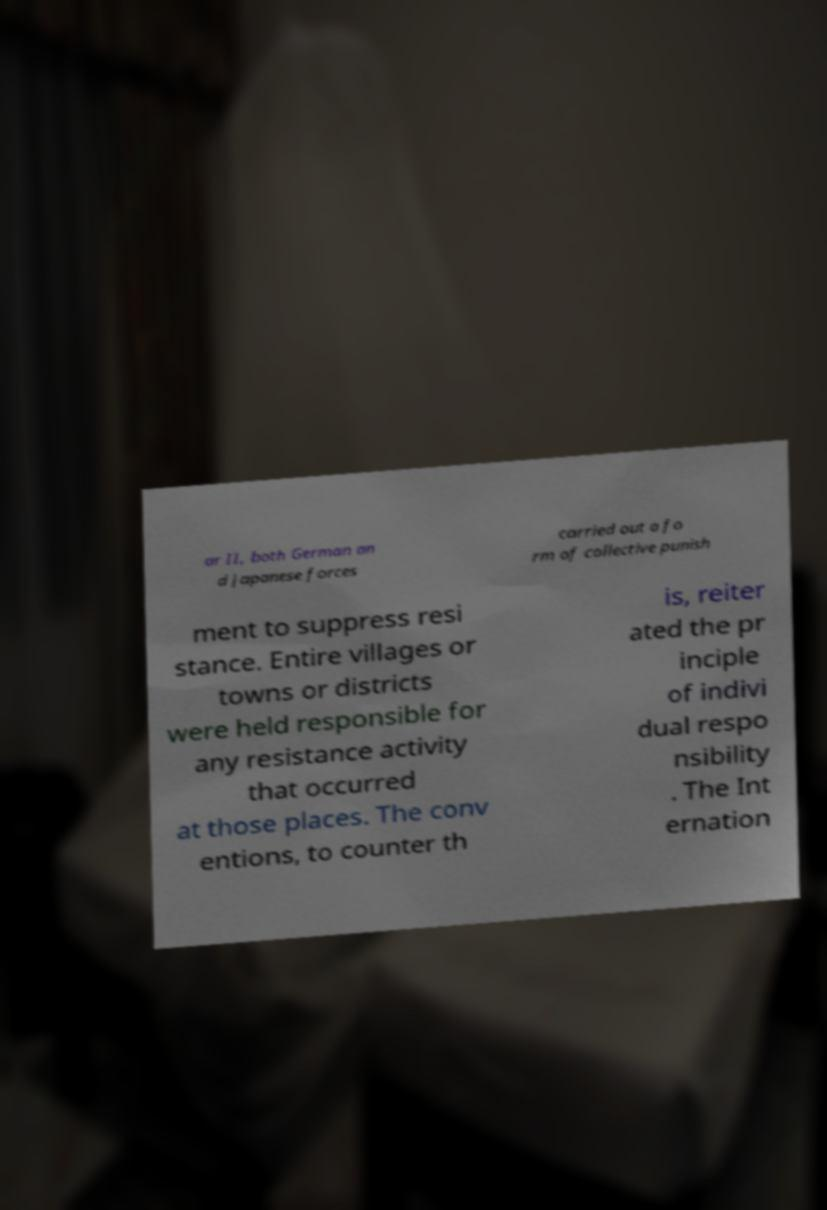Could you assist in decoding the text presented in this image and type it out clearly? ar II, both German an d Japanese forces carried out a fo rm of collective punish ment to suppress resi stance. Entire villages or towns or districts were held responsible for any resistance activity that occurred at those places. The conv entions, to counter th is, reiter ated the pr inciple of indivi dual respo nsibility . The Int ernation 